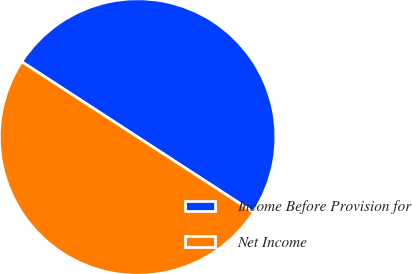Convert chart to OTSL. <chart><loc_0><loc_0><loc_500><loc_500><pie_chart><fcel>Income Before Provision for<fcel>Net Income<nl><fcel>50.0%<fcel>50.0%<nl></chart> 